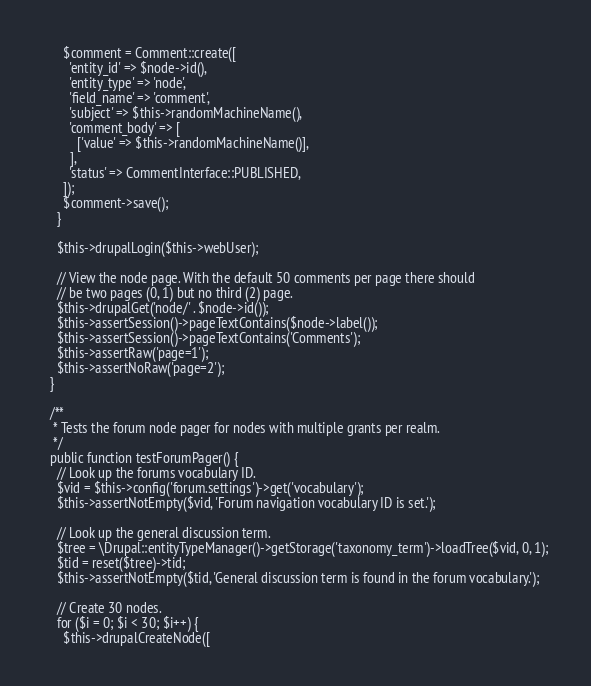<code> <loc_0><loc_0><loc_500><loc_500><_PHP_>      $comment = Comment::create([
        'entity_id' => $node->id(),
        'entity_type' => 'node',
        'field_name' => 'comment',
        'subject' => $this->randomMachineName(),
        'comment_body' => [
          ['value' => $this->randomMachineName()],
        ],
        'status' => CommentInterface::PUBLISHED,
      ]);
      $comment->save();
    }

    $this->drupalLogin($this->webUser);

    // View the node page. With the default 50 comments per page there should
    // be two pages (0, 1) but no third (2) page.
    $this->drupalGet('node/' . $node->id());
    $this->assertSession()->pageTextContains($node->label());
    $this->assertSession()->pageTextContains('Comments');
    $this->assertRaw('page=1');
    $this->assertNoRaw('page=2');
  }

  /**
   * Tests the forum node pager for nodes with multiple grants per realm.
   */
  public function testForumPager() {
    // Look up the forums vocabulary ID.
    $vid = $this->config('forum.settings')->get('vocabulary');
    $this->assertNotEmpty($vid, 'Forum navigation vocabulary ID is set.');

    // Look up the general discussion term.
    $tree = \Drupal::entityTypeManager()->getStorage('taxonomy_term')->loadTree($vid, 0, 1);
    $tid = reset($tree)->tid;
    $this->assertNotEmpty($tid, 'General discussion term is found in the forum vocabulary.');

    // Create 30 nodes.
    for ($i = 0; $i < 30; $i++) {
      $this->drupalCreateNode([</code> 